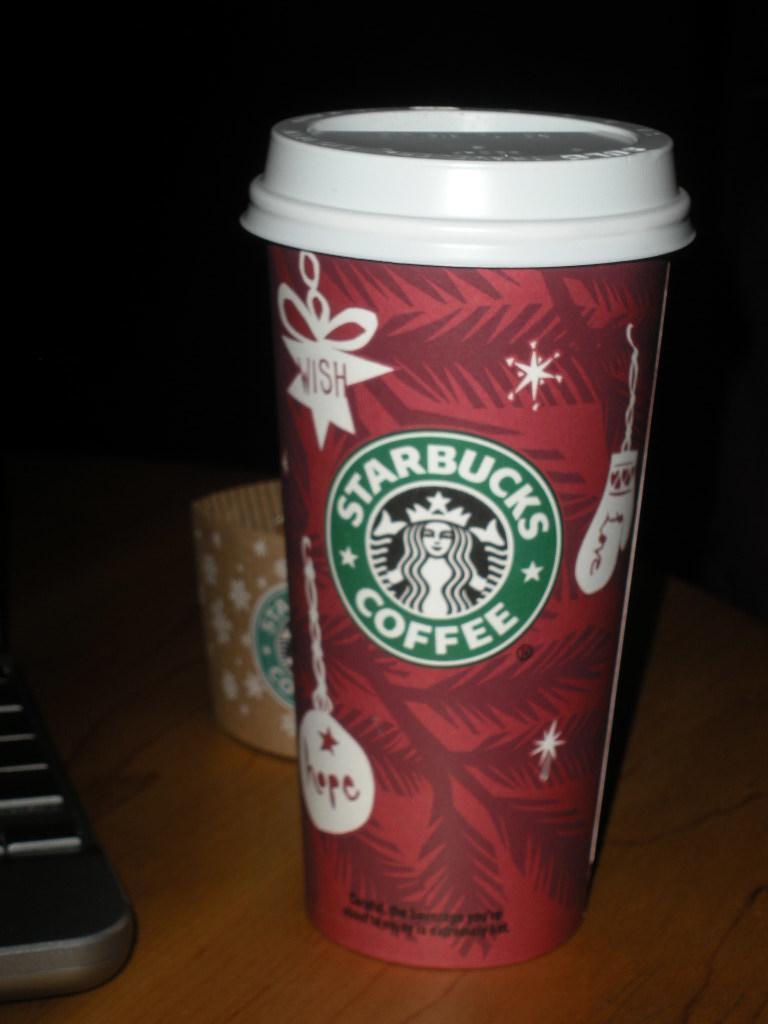Describe this image in one or two sentences. In this picture I can see a cup on the table and I can see dark background. 